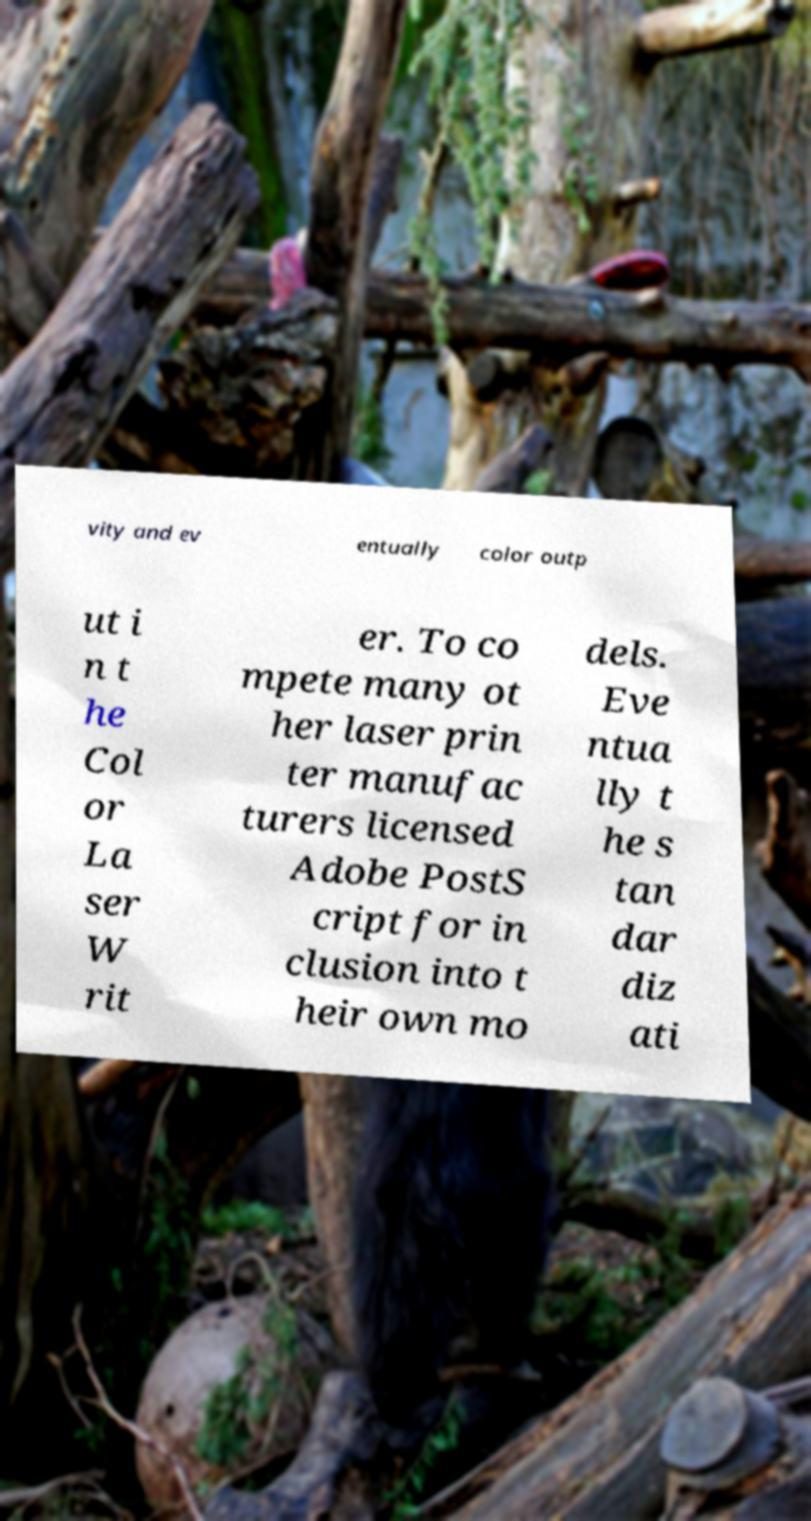What messages or text are displayed in this image? I need them in a readable, typed format. vity and ev entually color outp ut i n t he Col or La ser W rit er. To co mpete many ot her laser prin ter manufac turers licensed Adobe PostS cript for in clusion into t heir own mo dels. Eve ntua lly t he s tan dar diz ati 